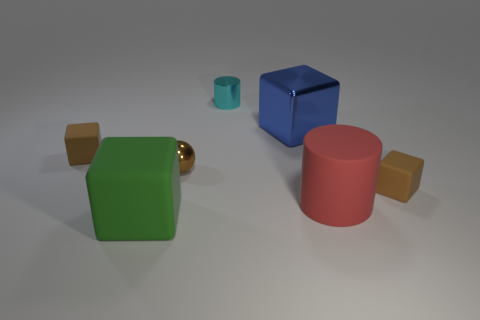Subtract 1 cubes. How many cubes are left? 3 Add 2 small green blocks. How many objects exist? 9 Subtract all cylinders. How many objects are left? 5 Subtract all small brown metal cylinders. Subtract all cyan metal things. How many objects are left? 6 Add 7 blue blocks. How many blue blocks are left? 8 Add 1 small purple shiny cubes. How many small purple shiny cubes exist? 1 Subtract 1 blue cubes. How many objects are left? 6 